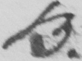What does this handwritten line say? B . 